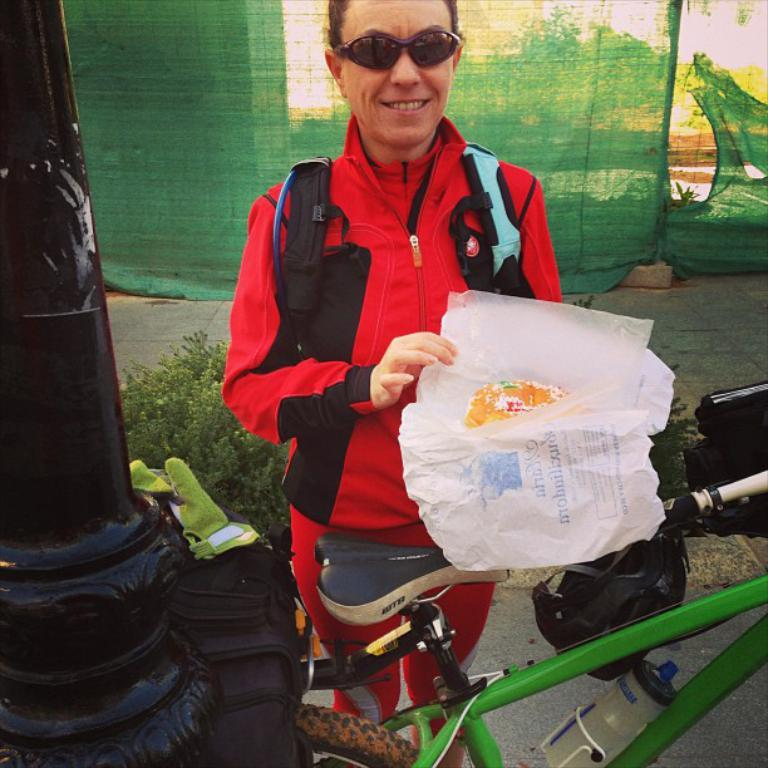What is the main subject of the image? There is a person standing in the image. Can you describe the person's appearance? The person is wearing glasses. What object is in front of the person? There is a bicycle in front of the person. What other item can be seen in the image? There is a bag in the image. What structure is visible in the image? There is a pole in the image. What type of vegetation is visible behind the person? There are plants visible behind the person. What type of vacation is the person planning based on the image? There is no information in the image to suggest that the person is planning a vacation. Can you describe the ray that is flying in the image? There is no ray present in the image; it is a person standing with a bicycle, bag, and pole in front of plants. 